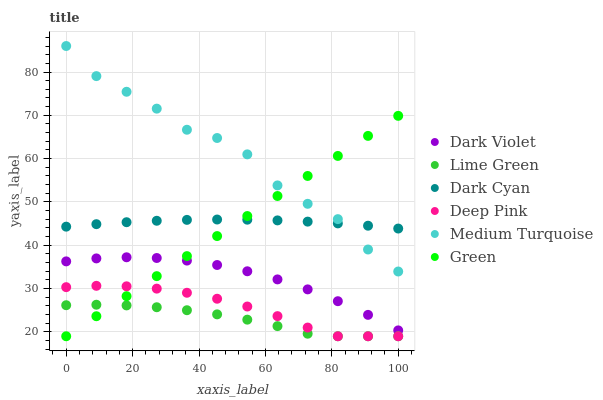Does Lime Green have the minimum area under the curve?
Answer yes or no. Yes. Does Medium Turquoise have the maximum area under the curve?
Answer yes or no. Yes. Does Dark Violet have the minimum area under the curve?
Answer yes or no. No. Does Dark Violet have the maximum area under the curve?
Answer yes or no. No. Is Green the smoothest?
Answer yes or no. Yes. Is Medium Turquoise the roughest?
Answer yes or no. Yes. Is Dark Violet the smoothest?
Answer yes or no. No. Is Dark Violet the roughest?
Answer yes or no. No. Does Deep Pink have the lowest value?
Answer yes or no. Yes. Does Dark Violet have the lowest value?
Answer yes or no. No. Does Medium Turquoise have the highest value?
Answer yes or no. Yes. Does Dark Violet have the highest value?
Answer yes or no. No. Is Dark Violet less than Medium Turquoise?
Answer yes or no. Yes. Is Medium Turquoise greater than Deep Pink?
Answer yes or no. Yes. Does Dark Violet intersect Green?
Answer yes or no. Yes. Is Dark Violet less than Green?
Answer yes or no. No. Is Dark Violet greater than Green?
Answer yes or no. No. Does Dark Violet intersect Medium Turquoise?
Answer yes or no. No. 